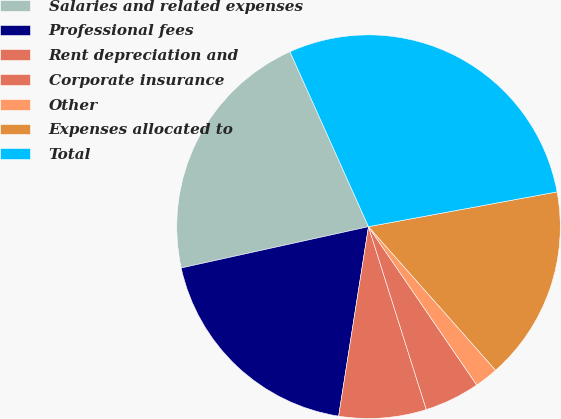<chart> <loc_0><loc_0><loc_500><loc_500><pie_chart><fcel>Salaries and related expenses<fcel>Professional fees<fcel>Rent depreciation and<fcel>Corporate insurance<fcel>Other<fcel>Expenses allocated to<fcel>Total<nl><fcel>21.74%<fcel>19.06%<fcel>7.36%<fcel>4.67%<fcel>1.99%<fcel>16.37%<fcel>28.81%<nl></chart> 